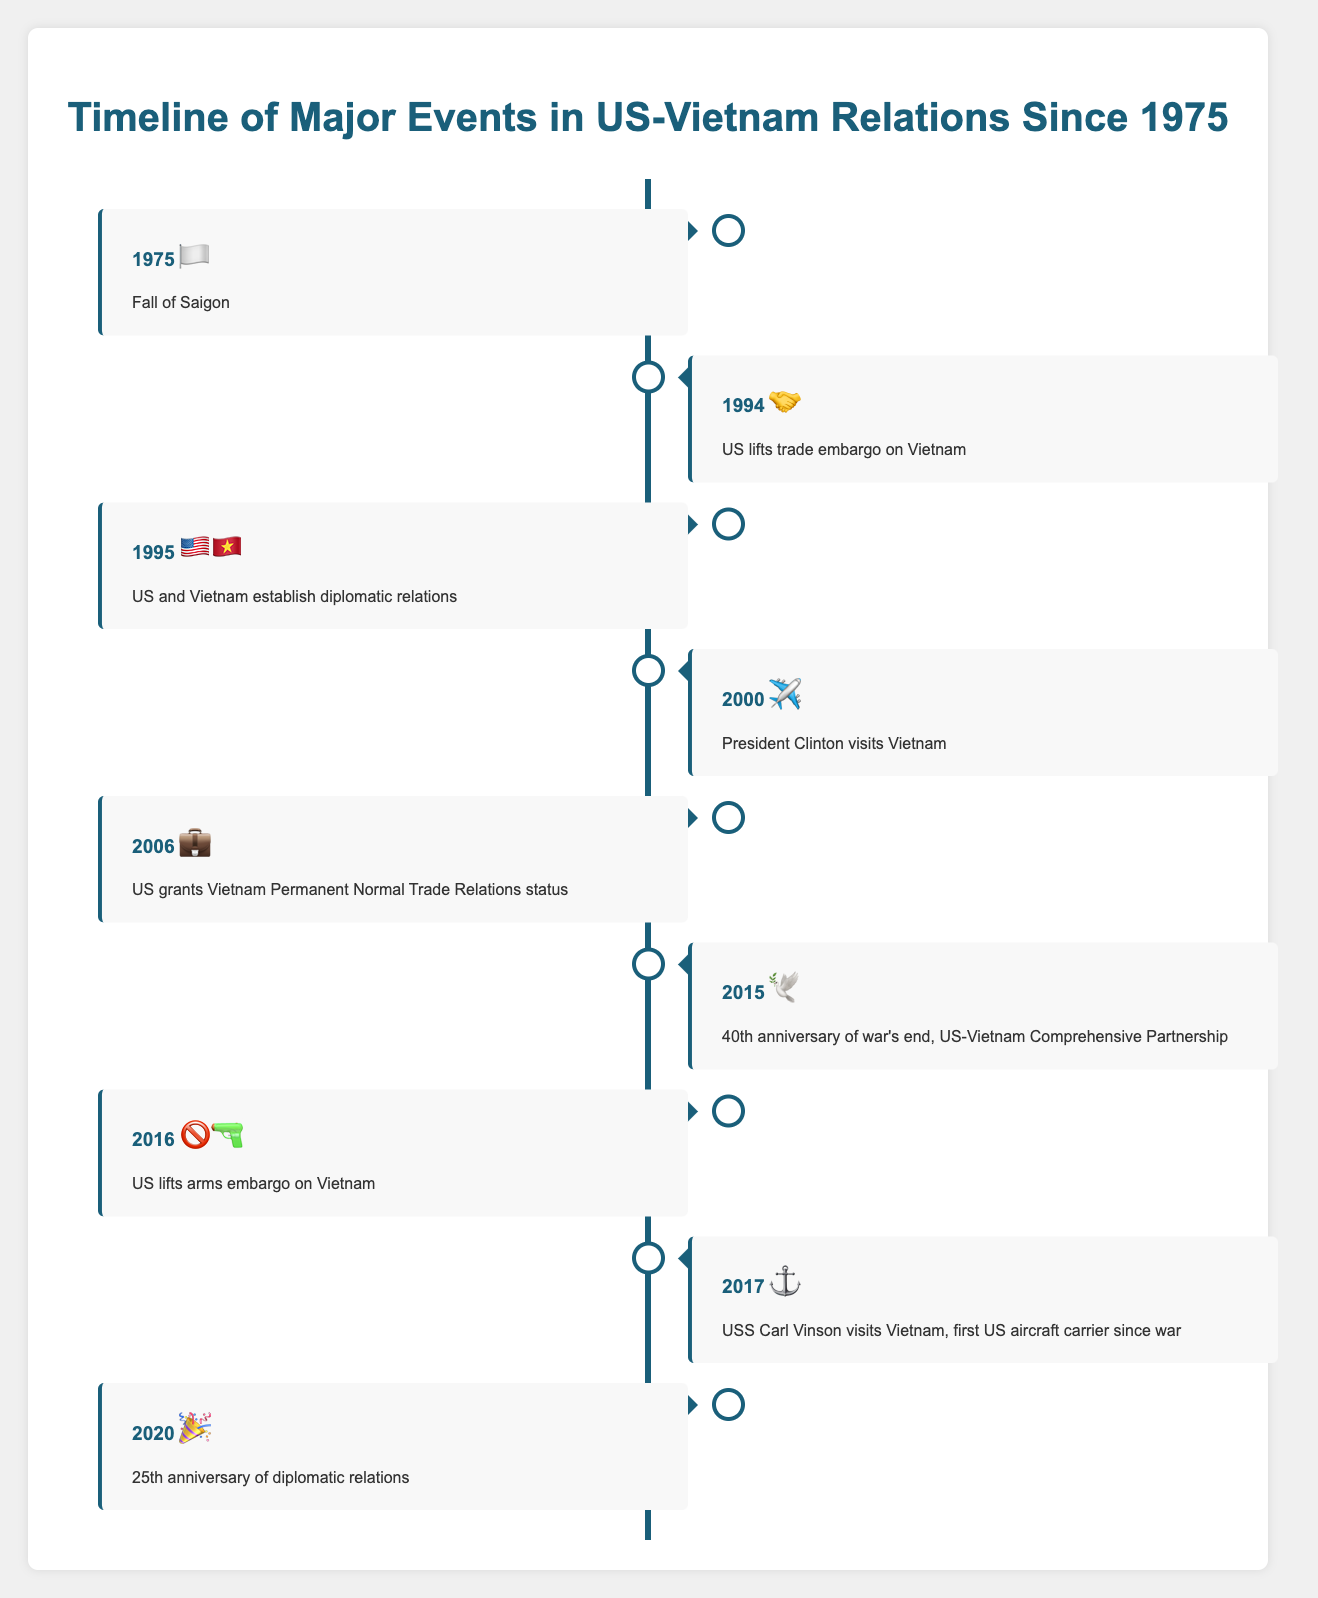What is the first event listed in the timeline? The first event listed in the timeline under the year 1975 is the "Fall of Saigon," represented by the flag emoji (🏳️).
Answer: Fall of Saigon Which event in the timeline is represented by the handshake emoji? The event represented by the handshake emoji (🤝) is "US lifts trade embargo on Vietnam," which occurred in 1994.
Answer: US lifts trade embargo on Vietnam How many years after the Fall of Saigon did the US establish diplomatic relations with Vietnam? The Fall of Saigon happened in 1975, and the US established diplomatic relations with Vietnam in 1995. To find the number of years between these events, subtract 1975 from 1995: 1995 - 1975 = 20.
Answer: 20 What significant event related to US-Vietnam relations happened in 2016? In 2016, the US lifted the arms embargo on Vietnam, represented by the emoji combination (🚫🔫).
Answer: US lifts arms embargo on Vietnam Which event is signified by the dove emoji, and in which year did it occur? The dove emoji (🕊️) signifies the "40th anniversary of war's end, US-Vietnam Comprehensive Partnership," which occurred in 2015.
Answer: 40th anniversary of war's end, US-Vietnam Comprehensive Partnership, 2015 What year did the USS Carl Vinson visit Vietnam, and what symbol is used to represent this event? The USS Carl Vinson's visit to Vietnam is represented by the anchor emoji (⚓), and this event occurred in 2017.
Answer: 2017, ⚓ Identify the event and year represented by the briefcase emoji. The briefcase emoji (💼) represents the "US grants Vietnam Permanent Normal Trade Relations status," which happened in 2006.
Answer: US grants Vietnam Permanent Normal Trade Relations status, 2006 How many years apart are the events "US and Vietnam establish diplomatic relations" and the "25th anniversary of diplomatic relations"? "US and Vietnam establish diplomatic relations" occurred in 1995, and the "25th anniversary of diplomatic relations" is in 2020. The number of years between these events is 2020 - 1995 = 25.
Answer: 25 Which two events occurred in the 1990s, and which emojis represent them? In the 1990s, two events occurred: "US lifts trade embargo on Vietnam" in 1994, represented by the handshake emoji (🤝), and "US and Vietnam establish diplomatic relations" in 1995, represented by the US and Vietnam flags emoji (🇺🇸🇻🇳).
Answer: US lifts trade embargo on Vietnam, 🤝; US and Vietnam establish diplomatic relations, 🇺🇸🇻🇳 